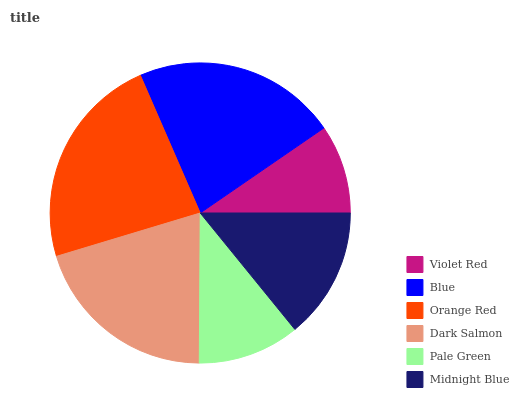Is Violet Red the minimum?
Answer yes or no. Yes. Is Orange Red the maximum?
Answer yes or no. Yes. Is Blue the minimum?
Answer yes or no. No. Is Blue the maximum?
Answer yes or no. No. Is Blue greater than Violet Red?
Answer yes or no. Yes. Is Violet Red less than Blue?
Answer yes or no. Yes. Is Violet Red greater than Blue?
Answer yes or no. No. Is Blue less than Violet Red?
Answer yes or no. No. Is Dark Salmon the high median?
Answer yes or no. Yes. Is Midnight Blue the low median?
Answer yes or no. Yes. Is Blue the high median?
Answer yes or no. No. Is Violet Red the low median?
Answer yes or no. No. 